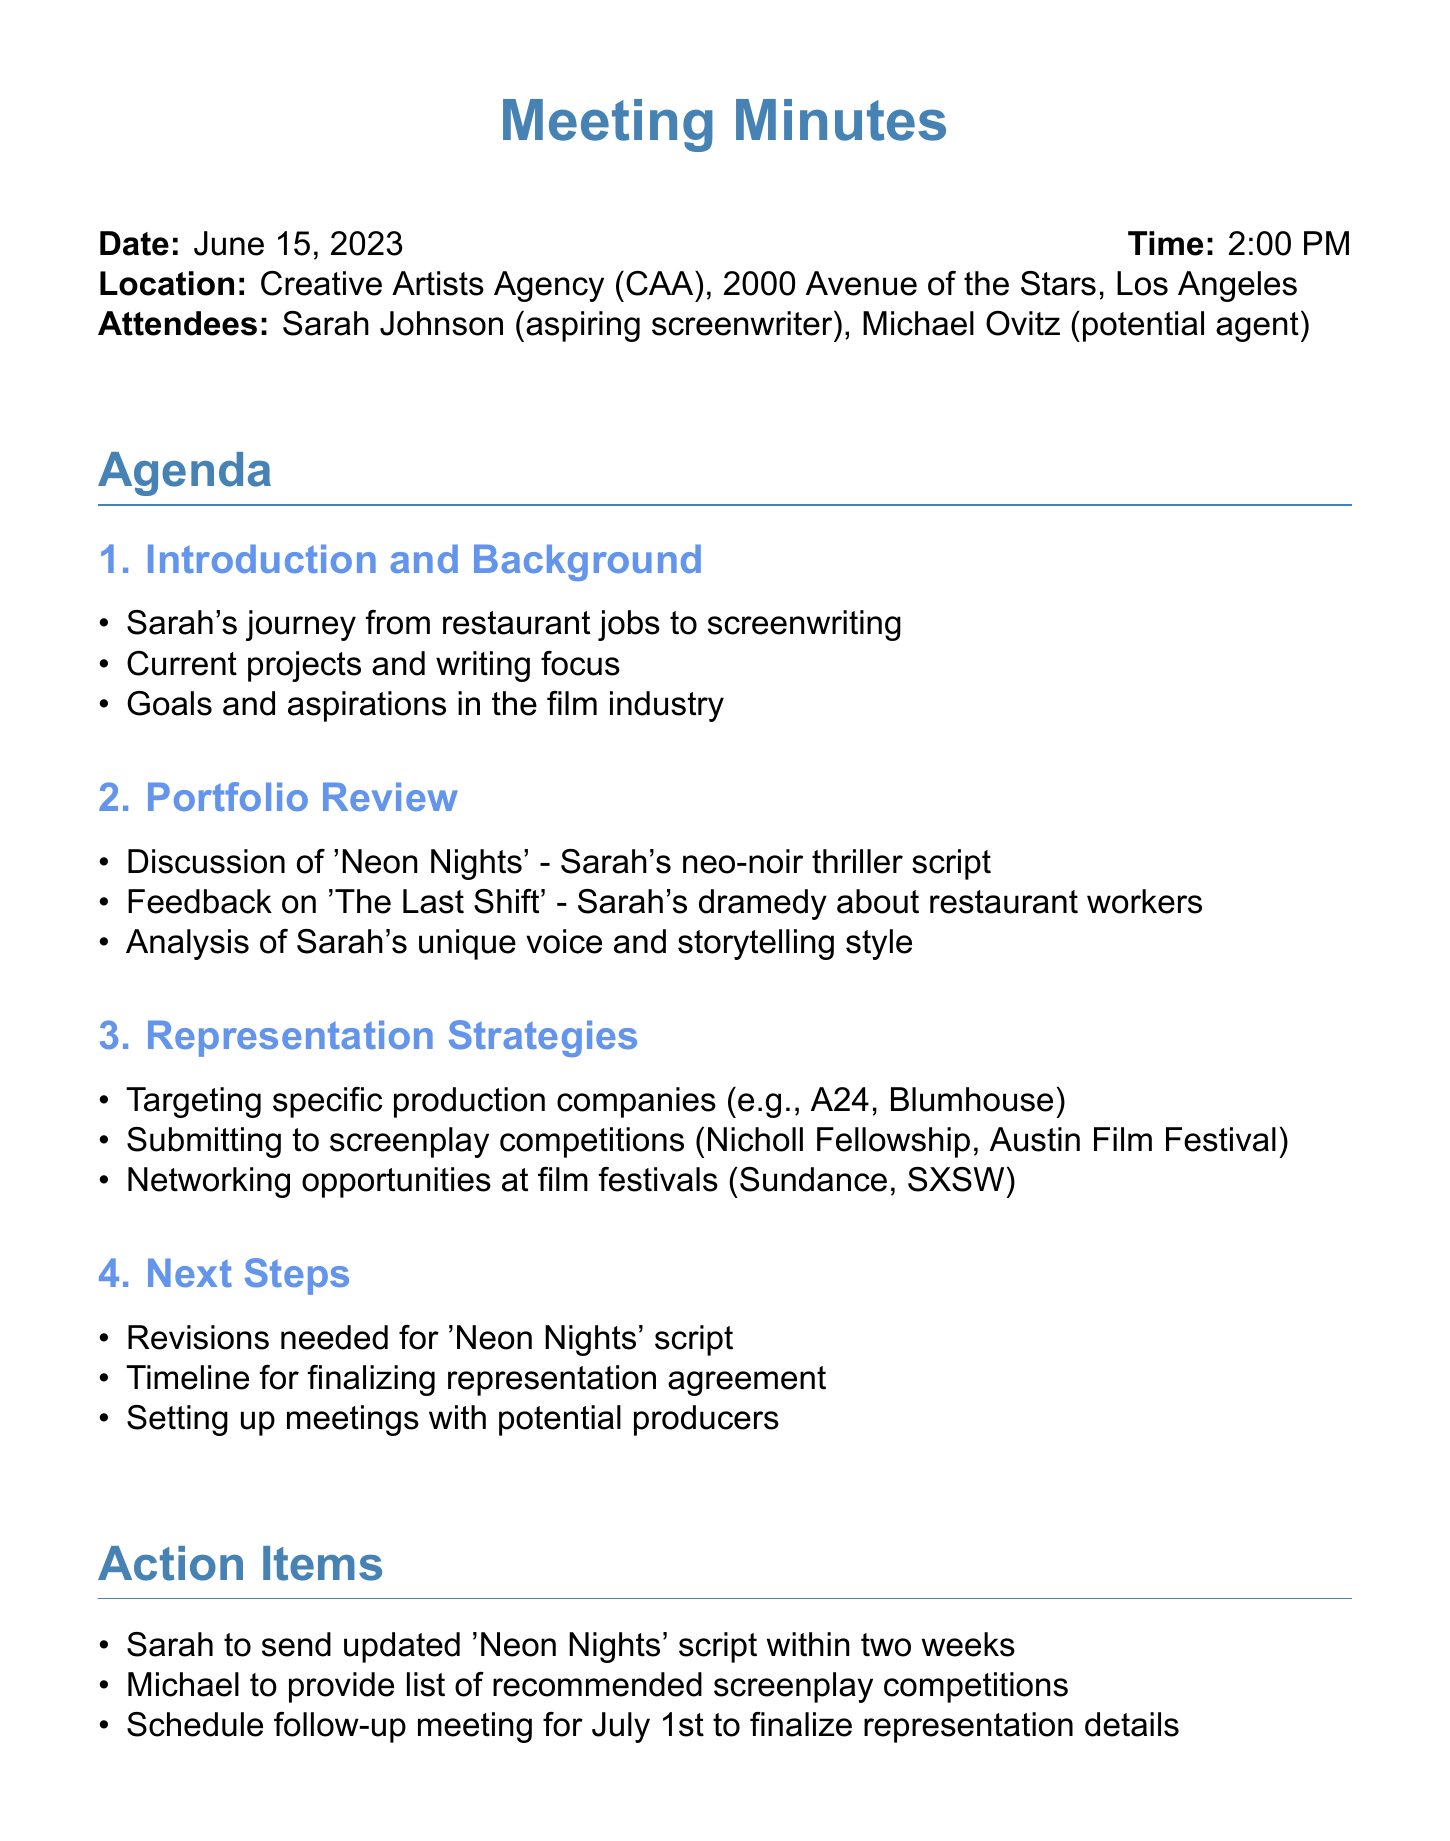What is the meeting date? The meeting date is explicitly mentioned in the document.
Answer: June 15, 2023 Who is the potential agent at the meeting? The document specifically lists the attendees, including the potential agent.
Answer: Michael Ovitz What script was discussed in the portfolio review? The document outlines the key points of the portfolio review, including specific script titles.
Answer: Neon Nights What is one targeted production company mentioned? The agenda item specifies targeting specific production companies during the representation strategies discussion.
Answer: A24 What is the follow-up meeting date? The action items section of the document lists the scheduled follow-up meeting date.
Answer: July 1st What feedback was given on 'The Last Shift'? The portfolio review includes feedback on the script, but does not provide details, prompting this reasoning question.
Answer: Feedback provided What is the location of the meeting? The document specifies the meeting location within the details.
Answer: Creative Artists Agency (CAA), 2000 Avenue of the Stars, Los Angeles How many weeks does Sarah have to send the updated script? The action items state the timeline for submitting the updated script.
Answer: Two weeks What is Sarah's main writing focus mentioned in the introduction? The agenda outlines Sarah's current projects and writing focus during the introduction.
Answer: Screenwriting 